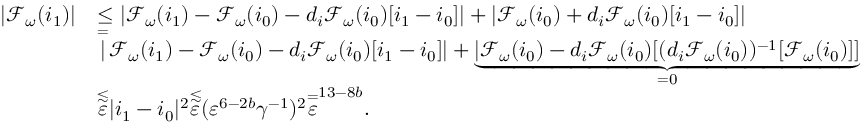<formula> <loc_0><loc_0><loc_500><loc_500>\begin{array} { r l } { | \mathcal { F } _ { \omega } ( i _ { 1 } ) | } & { \leq | \mathcal { F } _ { \omega } ( i _ { 1 } ) - \mathcal { F } _ { \omega } ( i _ { 0 } ) - d _ { i } \mathcal { F } _ { \omega } ( i _ { 0 } ) [ i _ { 1 } - i _ { 0 } ] | + | \mathcal { F } _ { \omega } ( i _ { 0 } ) + d _ { i } \mathcal { F } _ { \omega } ( i _ { 0 } ) [ i _ { 1 } - i _ { 0 } ] | } \\ & { \overset { = } { | } \mathcal { F } _ { \omega } ( i _ { 1 } ) - \mathcal { F } _ { \omega } ( i _ { 0 } ) - d _ { i } \mathcal { F } _ { \omega } ( i _ { 0 } ) [ i _ { 1 } - i _ { 0 } ] | + \underbrace { | \mathcal { F } _ { \omega } ( i _ { 0 } ) - d _ { i } \mathcal { F } _ { \omega } ( i _ { 0 } ) [ ( d _ { i } \mathcal { F } _ { \omega } ( i _ { 0 } ) ) ^ { - 1 } [ \mathcal { F } _ { \omega } ( i _ { 0 } ) ] ] } _ { = 0 } } \\ & { \overset { \lesssim } { \varepsilon } | i _ { 1 } - i _ { 0 } | ^ { 2 } \overset { \lesssim } { \varepsilon } ( \varepsilon ^ { 6 - 2 b } \gamma ^ { - 1 } ) ^ { 2 } \overset { = } { \varepsilon } ^ { 1 3 - 8 b } . } \end{array}</formula> 